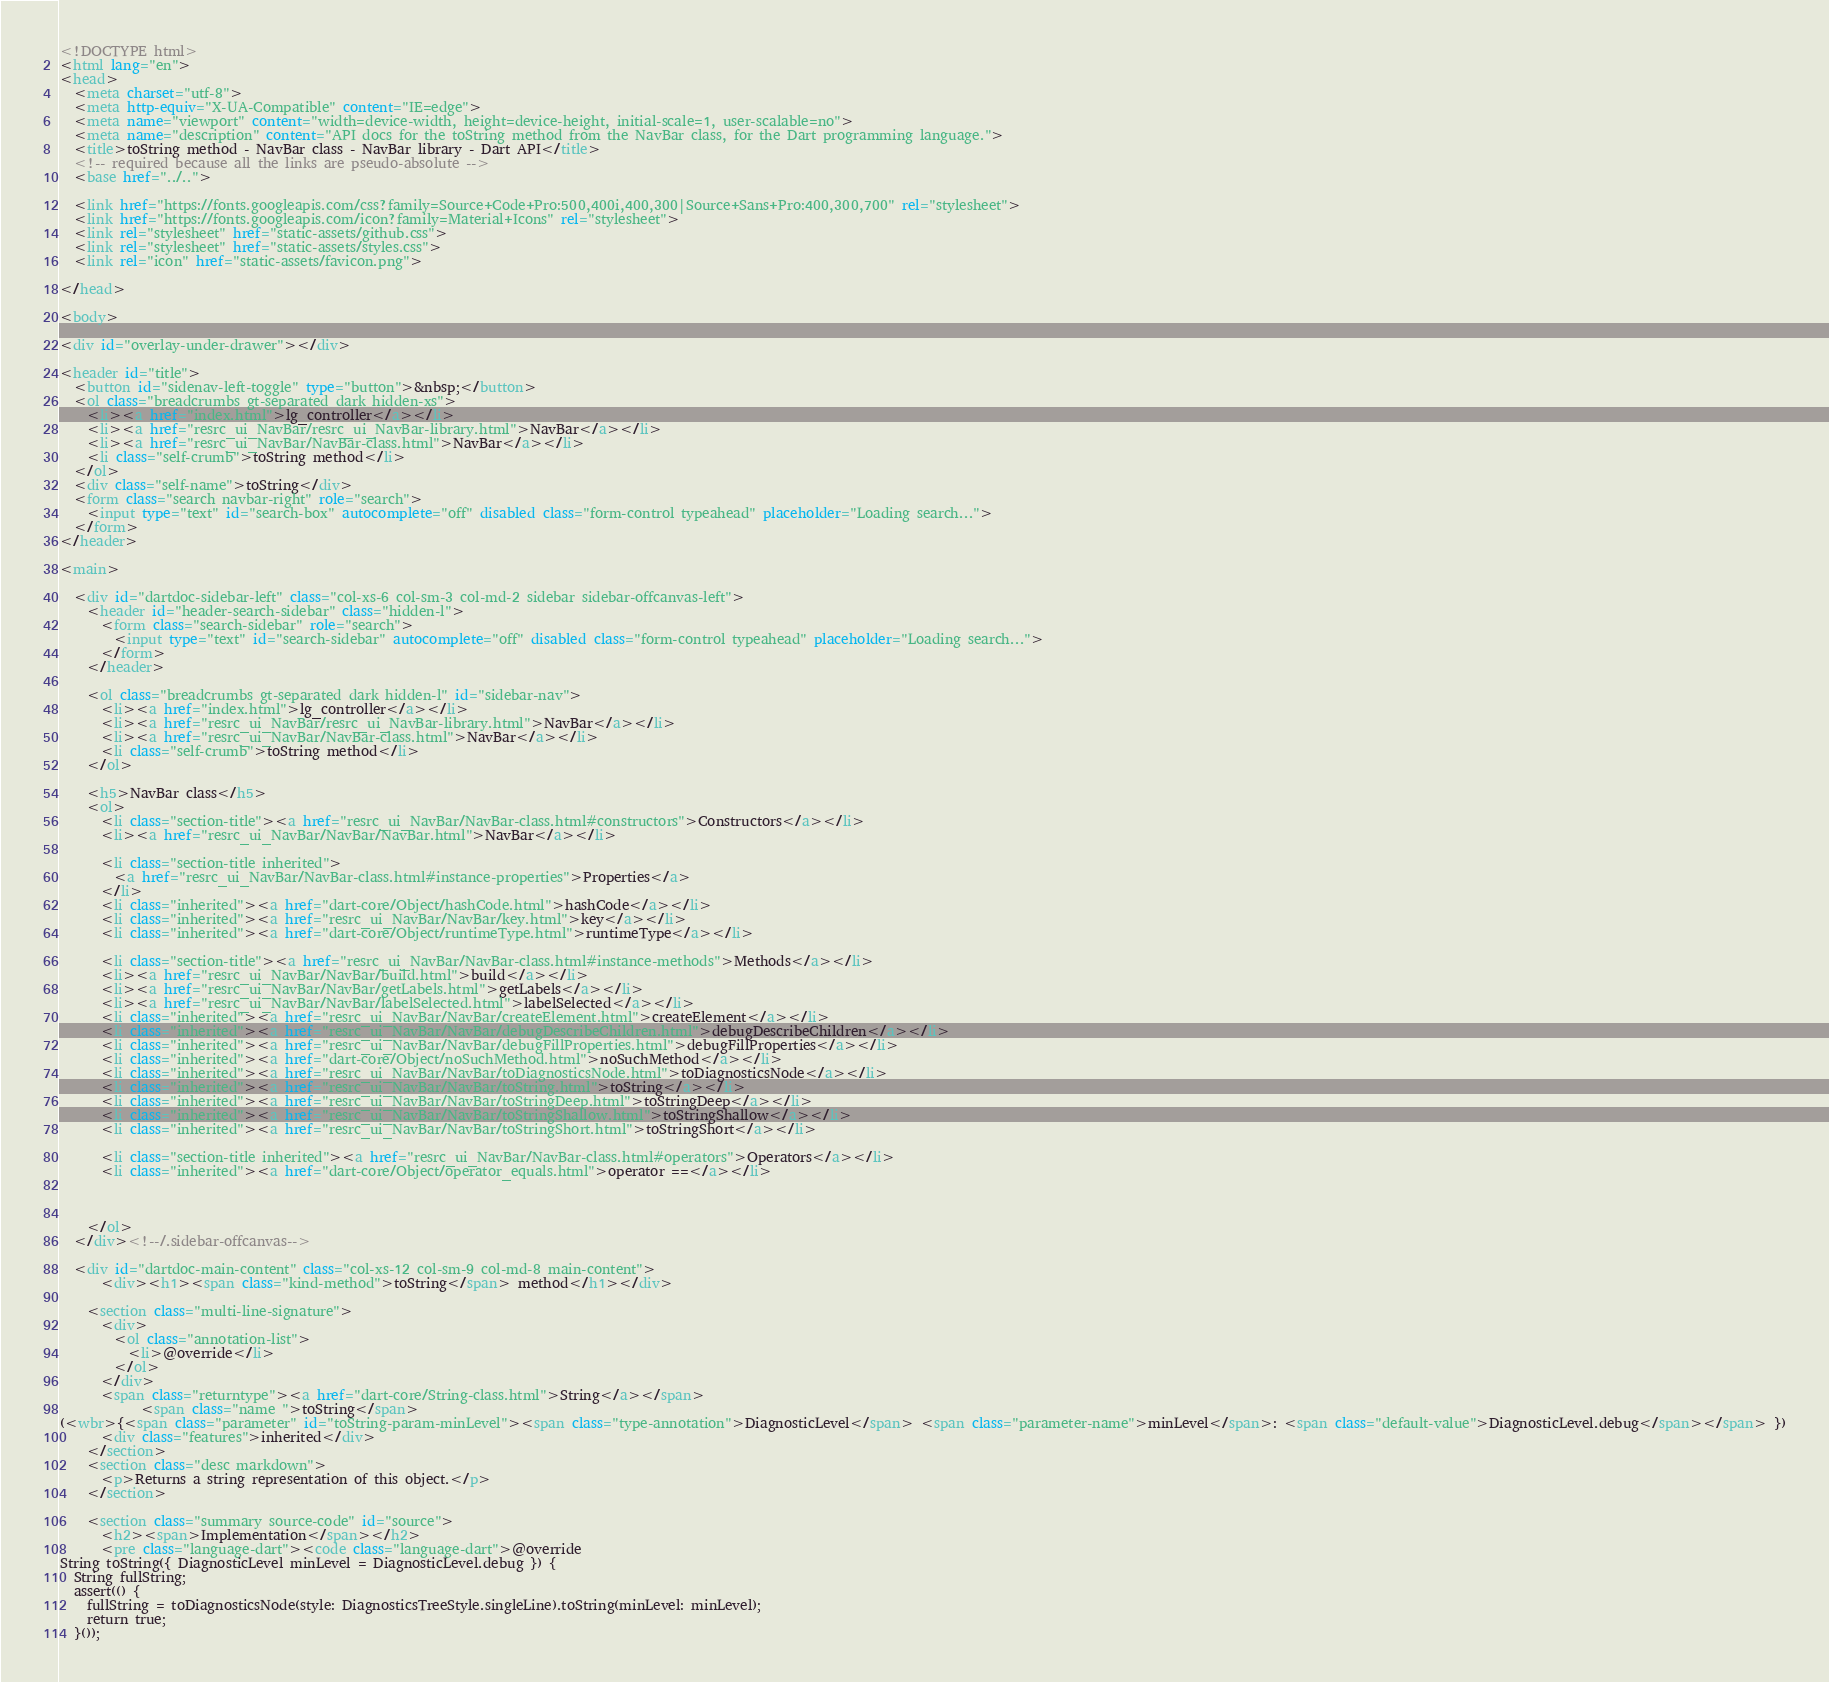<code> <loc_0><loc_0><loc_500><loc_500><_HTML_><!DOCTYPE html>
<html lang="en">
<head>
  <meta charset="utf-8">
  <meta http-equiv="X-UA-Compatible" content="IE=edge">
  <meta name="viewport" content="width=device-width, height=device-height, initial-scale=1, user-scalable=no">
  <meta name="description" content="API docs for the toString method from the NavBar class, for the Dart programming language.">
  <title>toString method - NavBar class - NavBar library - Dart API</title>
  <!-- required because all the links are pseudo-absolute -->
  <base href="../..">

  <link href="https://fonts.googleapis.com/css?family=Source+Code+Pro:500,400i,400,300|Source+Sans+Pro:400,300,700" rel="stylesheet">
  <link href="https://fonts.googleapis.com/icon?family=Material+Icons" rel="stylesheet">
  <link rel="stylesheet" href="static-assets/github.css">
  <link rel="stylesheet" href="static-assets/styles.css">
  <link rel="icon" href="static-assets/favicon.png">
  
</head>

<body>

<div id="overlay-under-drawer"></div>

<header id="title">
  <button id="sidenav-left-toggle" type="button">&nbsp;</button>
  <ol class="breadcrumbs gt-separated dark hidden-xs">
    <li><a href="index.html">lg_controller</a></li>
    <li><a href="resrc_ui_NavBar/resrc_ui_NavBar-library.html">NavBar</a></li>
    <li><a href="resrc_ui_NavBar/NavBar-class.html">NavBar</a></li>
    <li class="self-crumb">toString method</li>
  </ol>
  <div class="self-name">toString</div>
  <form class="search navbar-right" role="search">
    <input type="text" id="search-box" autocomplete="off" disabled class="form-control typeahead" placeholder="Loading search...">
  </form>
</header>

<main>

  <div id="dartdoc-sidebar-left" class="col-xs-6 col-sm-3 col-md-2 sidebar sidebar-offcanvas-left">
    <header id="header-search-sidebar" class="hidden-l">
      <form class="search-sidebar" role="search">
        <input type="text" id="search-sidebar" autocomplete="off" disabled class="form-control typeahead" placeholder="Loading search...">
      </form>
    </header>
    
    <ol class="breadcrumbs gt-separated dark hidden-l" id="sidebar-nav">
      <li><a href="index.html">lg_controller</a></li>
      <li><a href="resrc_ui_NavBar/resrc_ui_NavBar-library.html">NavBar</a></li>
      <li><a href="resrc_ui_NavBar/NavBar-class.html">NavBar</a></li>
      <li class="self-crumb">toString method</li>
    </ol>
    
    <h5>NavBar class</h5>
    <ol>
      <li class="section-title"><a href="resrc_ui_NavBar/NavBar-class.html#constructors">Constructors</a></li>
      <li><a href="resrc_ui_NavBar/NavBar/NavBar.html">NavBar</a></li>
    
      <li class="section-title inherited">
        <a href="resrc_ui_NavBar/NavBar-class.html#instance-properties">Properties</a>
      </li>
      <li class="inherited"><a href="dart-core/Object/hashCode.html">hashCode</a></li>
      <li class="inherited"><a href="resrc_ui_NavBar/NavBar/key.html">key</a></li>
      <li class="inherited"><a href="dart-core/Object/runtimeType.html">runtimeType</a></li>
    
      <li class="section-title"><a href="resrc_ui_NavBar/NavBar-class.html#instance-methods">Methods</a></li>
      <li><a href="resrc_ui_NavBar/NavBar/build.html">build</a></li>
      <li><a href="resrc_ui_NavBar/NavBar/getLabels.html">getLabels</a></li>
      <li><a href="resrc_ui_NavBar/NavBar/labelSelected.html">labelSelected</a></li>
      <li class="inherited"><a href="resrc_ui_NavBar/NavBar/createElement.html">createElement</a></li>
      <li class="inherited"><a href="resrc_ui_NavBar/NavBar/debugDescribeChildren.html">debugDescribeChildren</a></li>
      <li class="inherited"><a href="resrc_ui_NavBar/NavBar/debugFillProperties.html">debugFillProperties</a></li>
      <li class="inherited"><a href="dart-core/Object/noSuchMethod.html">noSuchMethod</a></li>
      <li class="inherited"><a href="resrc_ui_NavBar/NavBar/toDiagnosticsNode.html">toDiagnosticsNode</a></li>
      <li class="inherited"><a href="resrc_ui_NavBar/NavBar/toString.html">toString</a></li>
      <li class="inherited"><a href="resrc_ui_NavBar/NavBar/toStringDeep.html">toStringDeep</a></li>
      <li class="inherited"><a href="resrc_ui_NavBar/NavBar/toStringShallow.html">toStringShallow</a></li>
      <li class="inherited"><a href="resrc_ui_NavBar/NavBar/toStringShort.html">toStringShort</a></li>
    
      <li class="section-title inherited"><a href="resrc_ui_NavBar/NavBar-class.html#operators">Operators</a></li>
      <li class="inherited"><a href="dart-core/Object/operator_equals.html">operator ==</a></li>
    
    
    
    </ol>
  </div><!--/.sidebar-offcanvas-->

  <div id="dartdoc-main-content" class="col-xs-12 col-sm-9 col-md-8 main-content">
      <div><h1><span class="kind-method">toString</span> method</h1></div>

    <section class="multi-line-signature">
      <div>
        <ol class="annotation-list">
          <li>@override</li>
        </ol>
      </div>
      <span class="returntype"><a href="dart-core/String-class.html">String</a></span>
            <span class="name ">toString</span>
(<wbr>{<span class="parameter" id="toString-param-minLevel"><span class="type-annotation">DiagnosticLevel</span> <span class="parameter-name">minLevel</span>: <span class="default-value">DiagnosticLevel.debug</span></span> })
      <div class="features">inherited</div>
    </section>
    <section class="desc markdown">
      <p>Returns a string representation of this object.</p>
    </section>
    
    <section class="summary source-code" id="source">
      <h2><span>Implementation</span></h2>
      <pre class="language-dart"><code class="language-dart">@override
String toString({ DiagnosticLevel minLevel = DiagnosticLevel.debug }) {
  String fullString;
  assert(() {
    fullString = toDiagnosticsNode(style: DiagnosticsTreeStyle.singleLine).toString(minLevel: minLevel);
    return true;
  }());</code> 